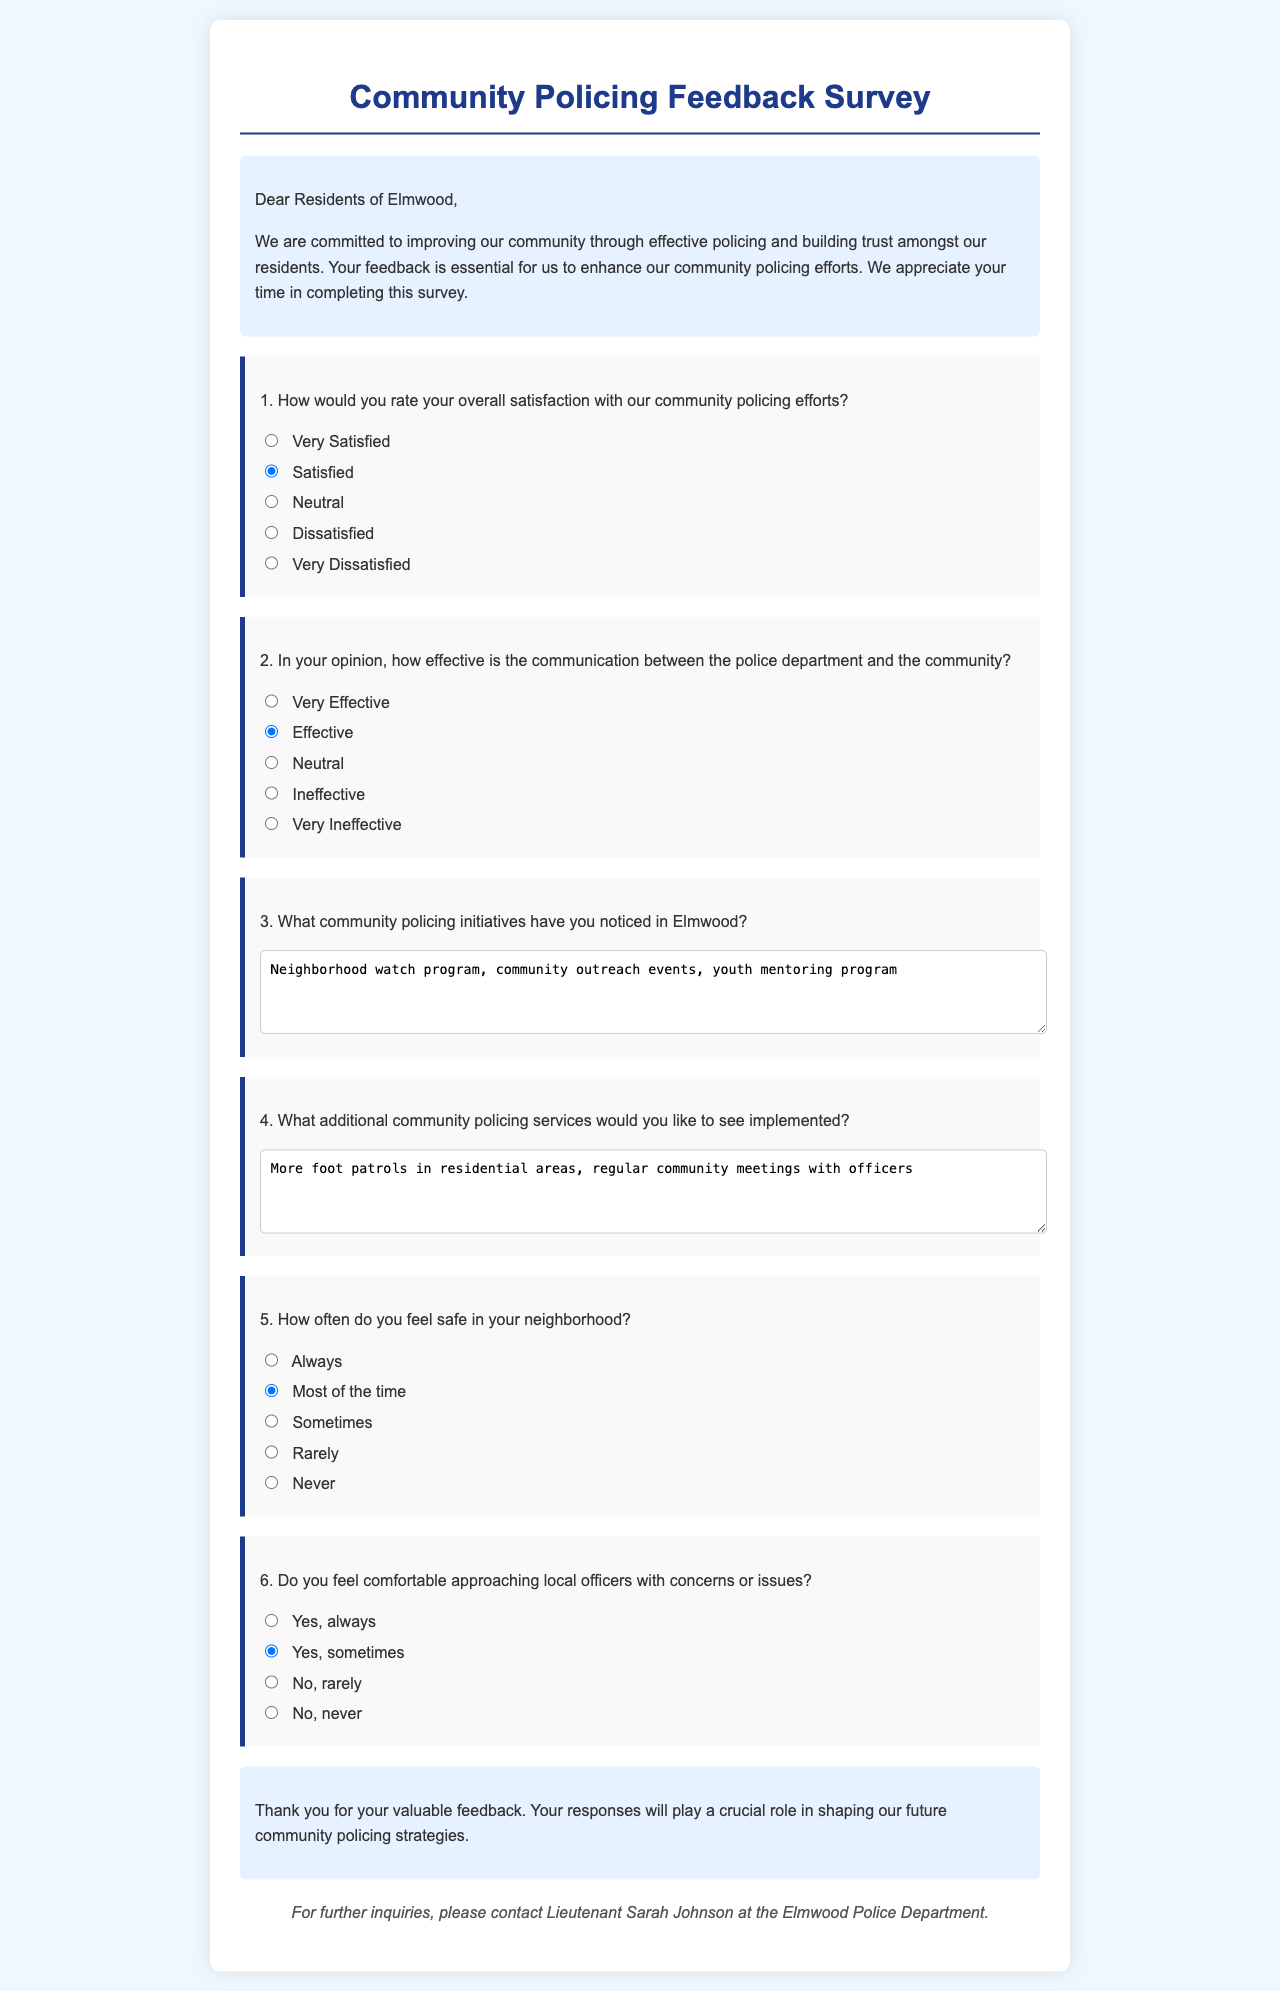What is the title of the document? The title is displayed prominently at the top of the document, indicating its purpose.
Answer: Community Policing Feedback Survey Who is the intended audience for the survey? The introductory section of the document addresses the residents, indicating who the survey is intended for.
Answer: Residents of Elmwood How many questions are included in the survey? The document lists six questions, providing an overview of the feedback sought.
Answer: Six What is the first response option for overall satisfaction? The first response option for question one is explicitly stated in the document as the first choice available.
Answer: Very Satisfied What initiative was specifically mentioned by the respondents? The respondents noted community initiatives in their answers to question three, which highlights the efforts made by the police department.
Answer: Neighborhood watch program How often do residents feel safe in their neighborhood according to the options? The survey provides multiple-choice responses illustrating residents' feelings about safety, with one option mentioning frequency.
Answer: Always 